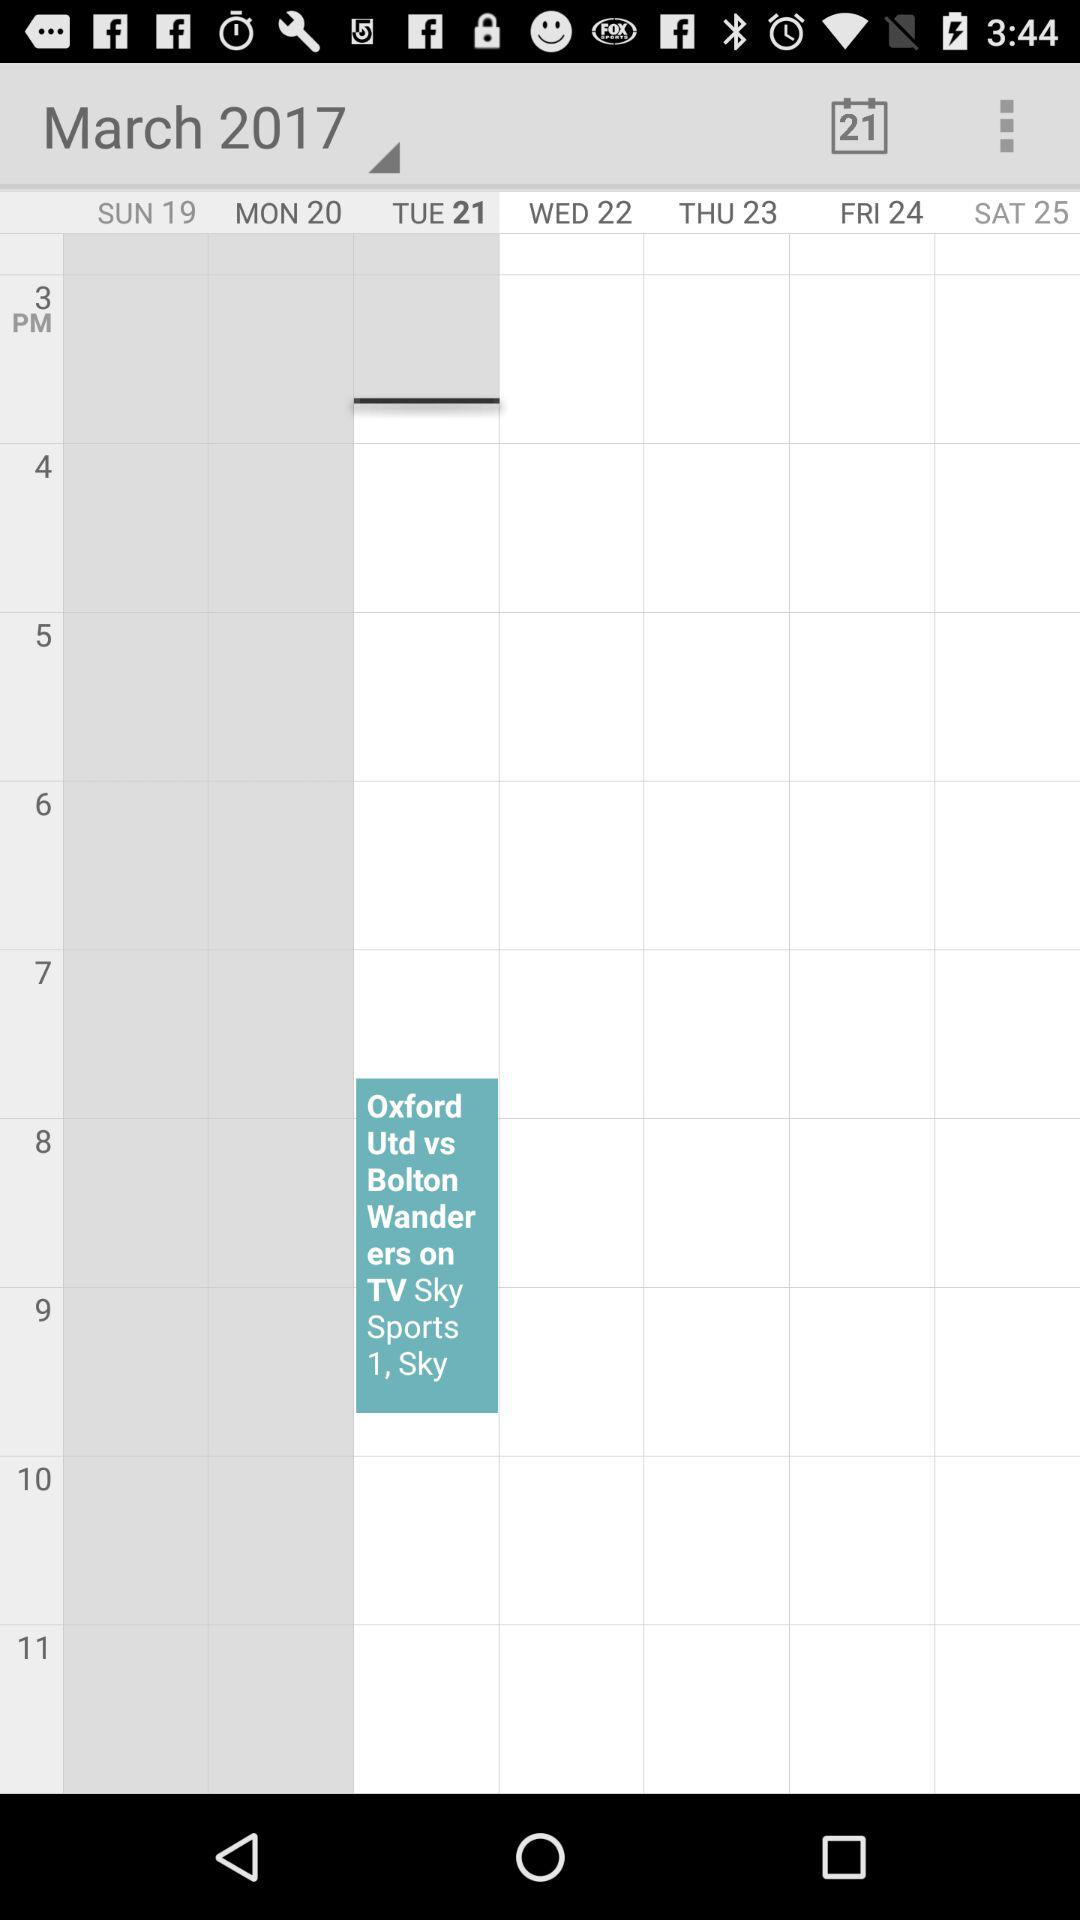What is the selected year? The selected year is 2017. 